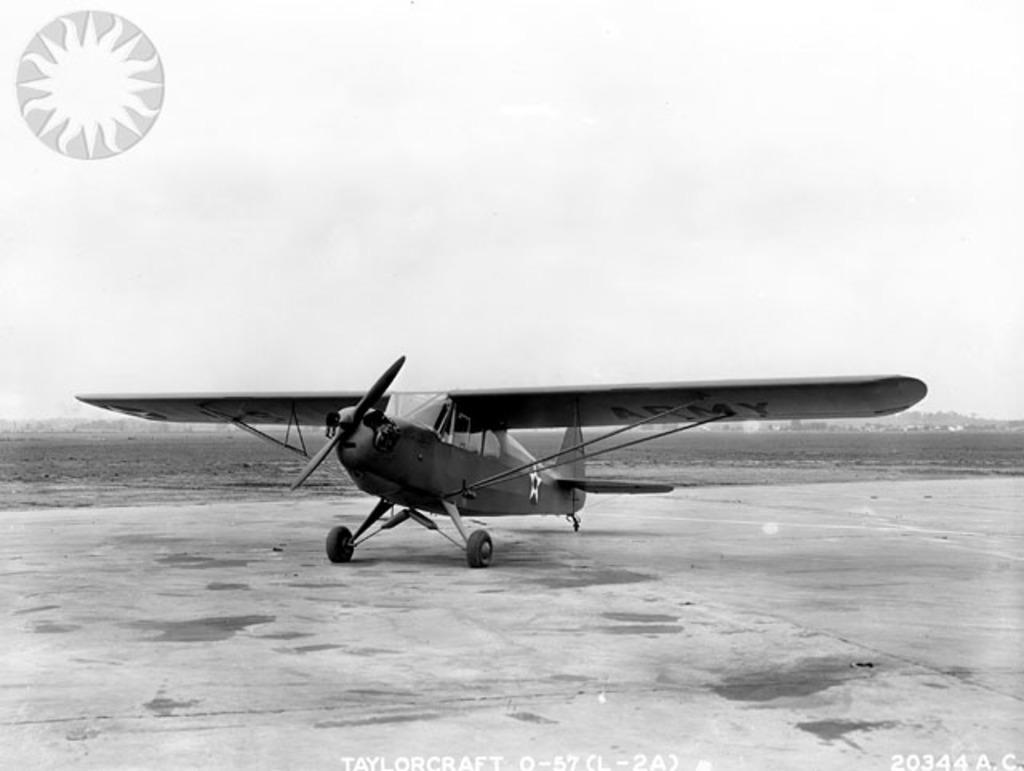Can you describe this image briefly? In this image I can see an aeroplane on the ground. In the background I can see in the sky. Here I can see a logo and a watermark. This picture is black and white in color. 